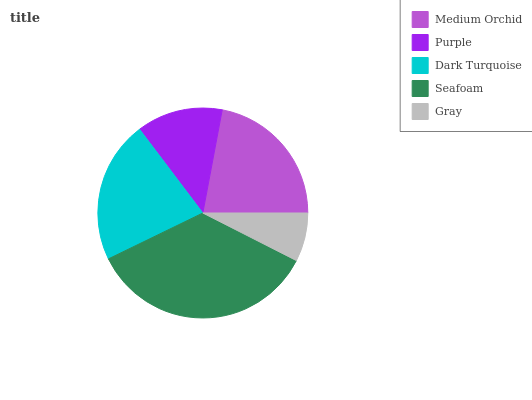Is Gray the minimum?
Answer yes or no. Yes. Is Seafoam the maximum?
Answer yes or no. Yes. Is Purple the minimum?
Answer yes or no. No. Is Purple the maximum?
Answer yes or no. No. Is Medium Orchid greater than Purple?
Answer yes or no. Yes. Is Purple less than Medium Orchid?
Answer yes or no. Yes. Is Purple greater than Medium Orchid?
Answer yes or no. No. Is Medium Orchid less than Purple?
Answer yes or no. No. Is Dark Turquoise the high median?
Answer yes or no. Yes. Is Dark Turquoise the low median?
Answer yes or no. Yes. Is Purple the high median?
Answer yes or no. No. Is Gray the low median?
Answer yes or no. No. 